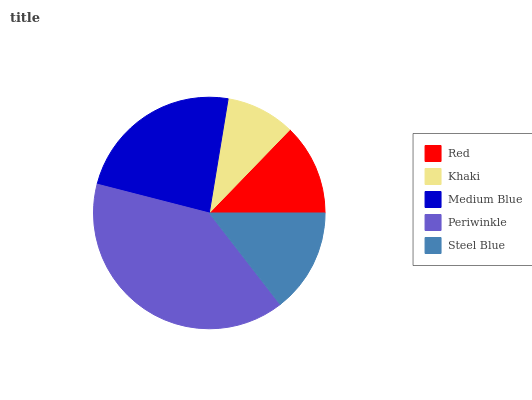Is Khaki the minimum?
Answer yes or no. Yes. Is Periwinkle the maximum?
Answer yes or no. Yes. Is Medium Blue the minimum?
Answer yes or no. No. Is Medium Blue the maximum?
Answer yes or no. No. Is Medium Blue greater than Khaki?
Answer yes or no. Yes. Is Khaki less than Medium Blue?
Answer yes or no. Yes. Is Khaki greater than Medium Blue?
Answer yes or no. No. Is Medium Blue less than Khaki?
Answer yes or no. No. Is Steel Blue the high median?
Answer yes or no. Yes. Is Steel Blue the low median?
Answer yes or no. Yes. Is Khaki the high median?
Answer yes or no. No. Is Khaki the low median?
Answer yes or no. No. 